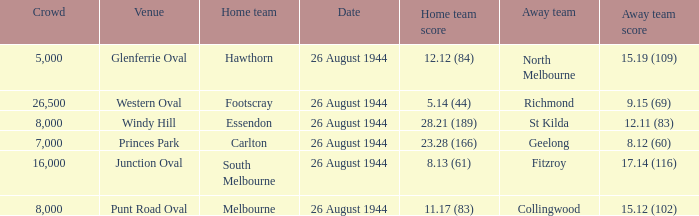Help me parse the entirety of this table. {'header': ['Crowd', 'Venue', 'Home team', 'Date', 'Home team score', 'Away team', 'Away team score'], 'rows': [['5,000', 'Glenferrie Oval', 'Hawthorn', '26 August 1944', '12.12 (84)', 'North Melbourne', '15.19 (109)'], ['26,500', 'Western Oval', 'Footscray', '26 August 1944', '5.14 (44)', 'Richmond', '9.15 (69)'], ['8,000', 'Windy Hill', 'Essendon', '26 August 1944', '28.21 (189)', 'St Kilda', '12.11 (83)'], ['7,000', 'Princes Park', 'Carlton', '26 August 1944', '23.28 (166)', 'Geelong', '8.12 (60)'], ['16,000', 'Junction Oval', 'South Melbourne', '26 August 1944', '8.13 (61)', 'Fitzroy', '17.14 (116)'], ['8,000', 'Punt Road Oval', 'Melbourne', '26 August 1944', '11.17 (83)', 'Collingwood', '15.12 (102)']]} What's the average crowd size when the Home team is melbourne? 8000.0. 